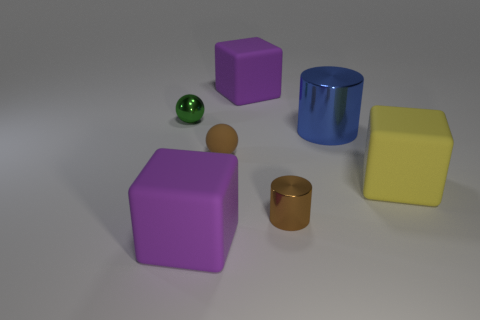Add 2 purple blocks. How many objects exist? 9 Subtract all green cubes. Subtract all green cylinders. How many cubes are left? 3 Subtract all cylinders. How many objects are left? 5 Add 3 large yellow matte things. How many large yellow matte things exist? 4 Subtract 1 yellow cubes. How many objects are left? 6 Subtract all metal cylinders. Subtract all large yellow objects. How many objects are left? 4 Add 6 small green shiny objects. How many small green shiny objects are left? 7 